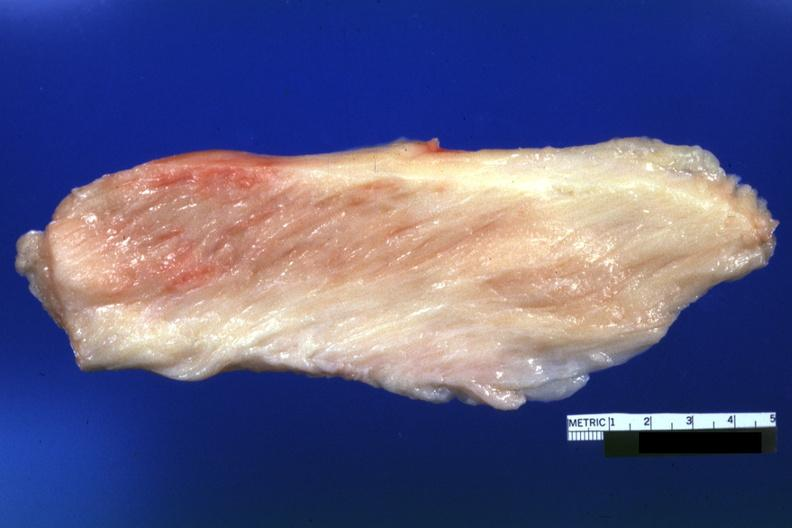does this image show white muscle?
Answer the question using a single word or phrase. Yes 